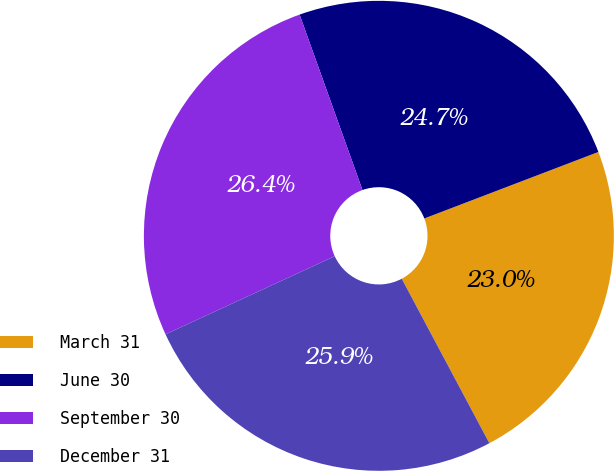<chart> <loc_0><loc_0><loc_500><loc_500><pie_chart><fcel>March 31<fcel>June 30<fcel>September 30<fcel>December 31<nl><fcel>23.02%<fcel>24.67%<fcel>26.41%<fcel>25.91%<nl></chart> 